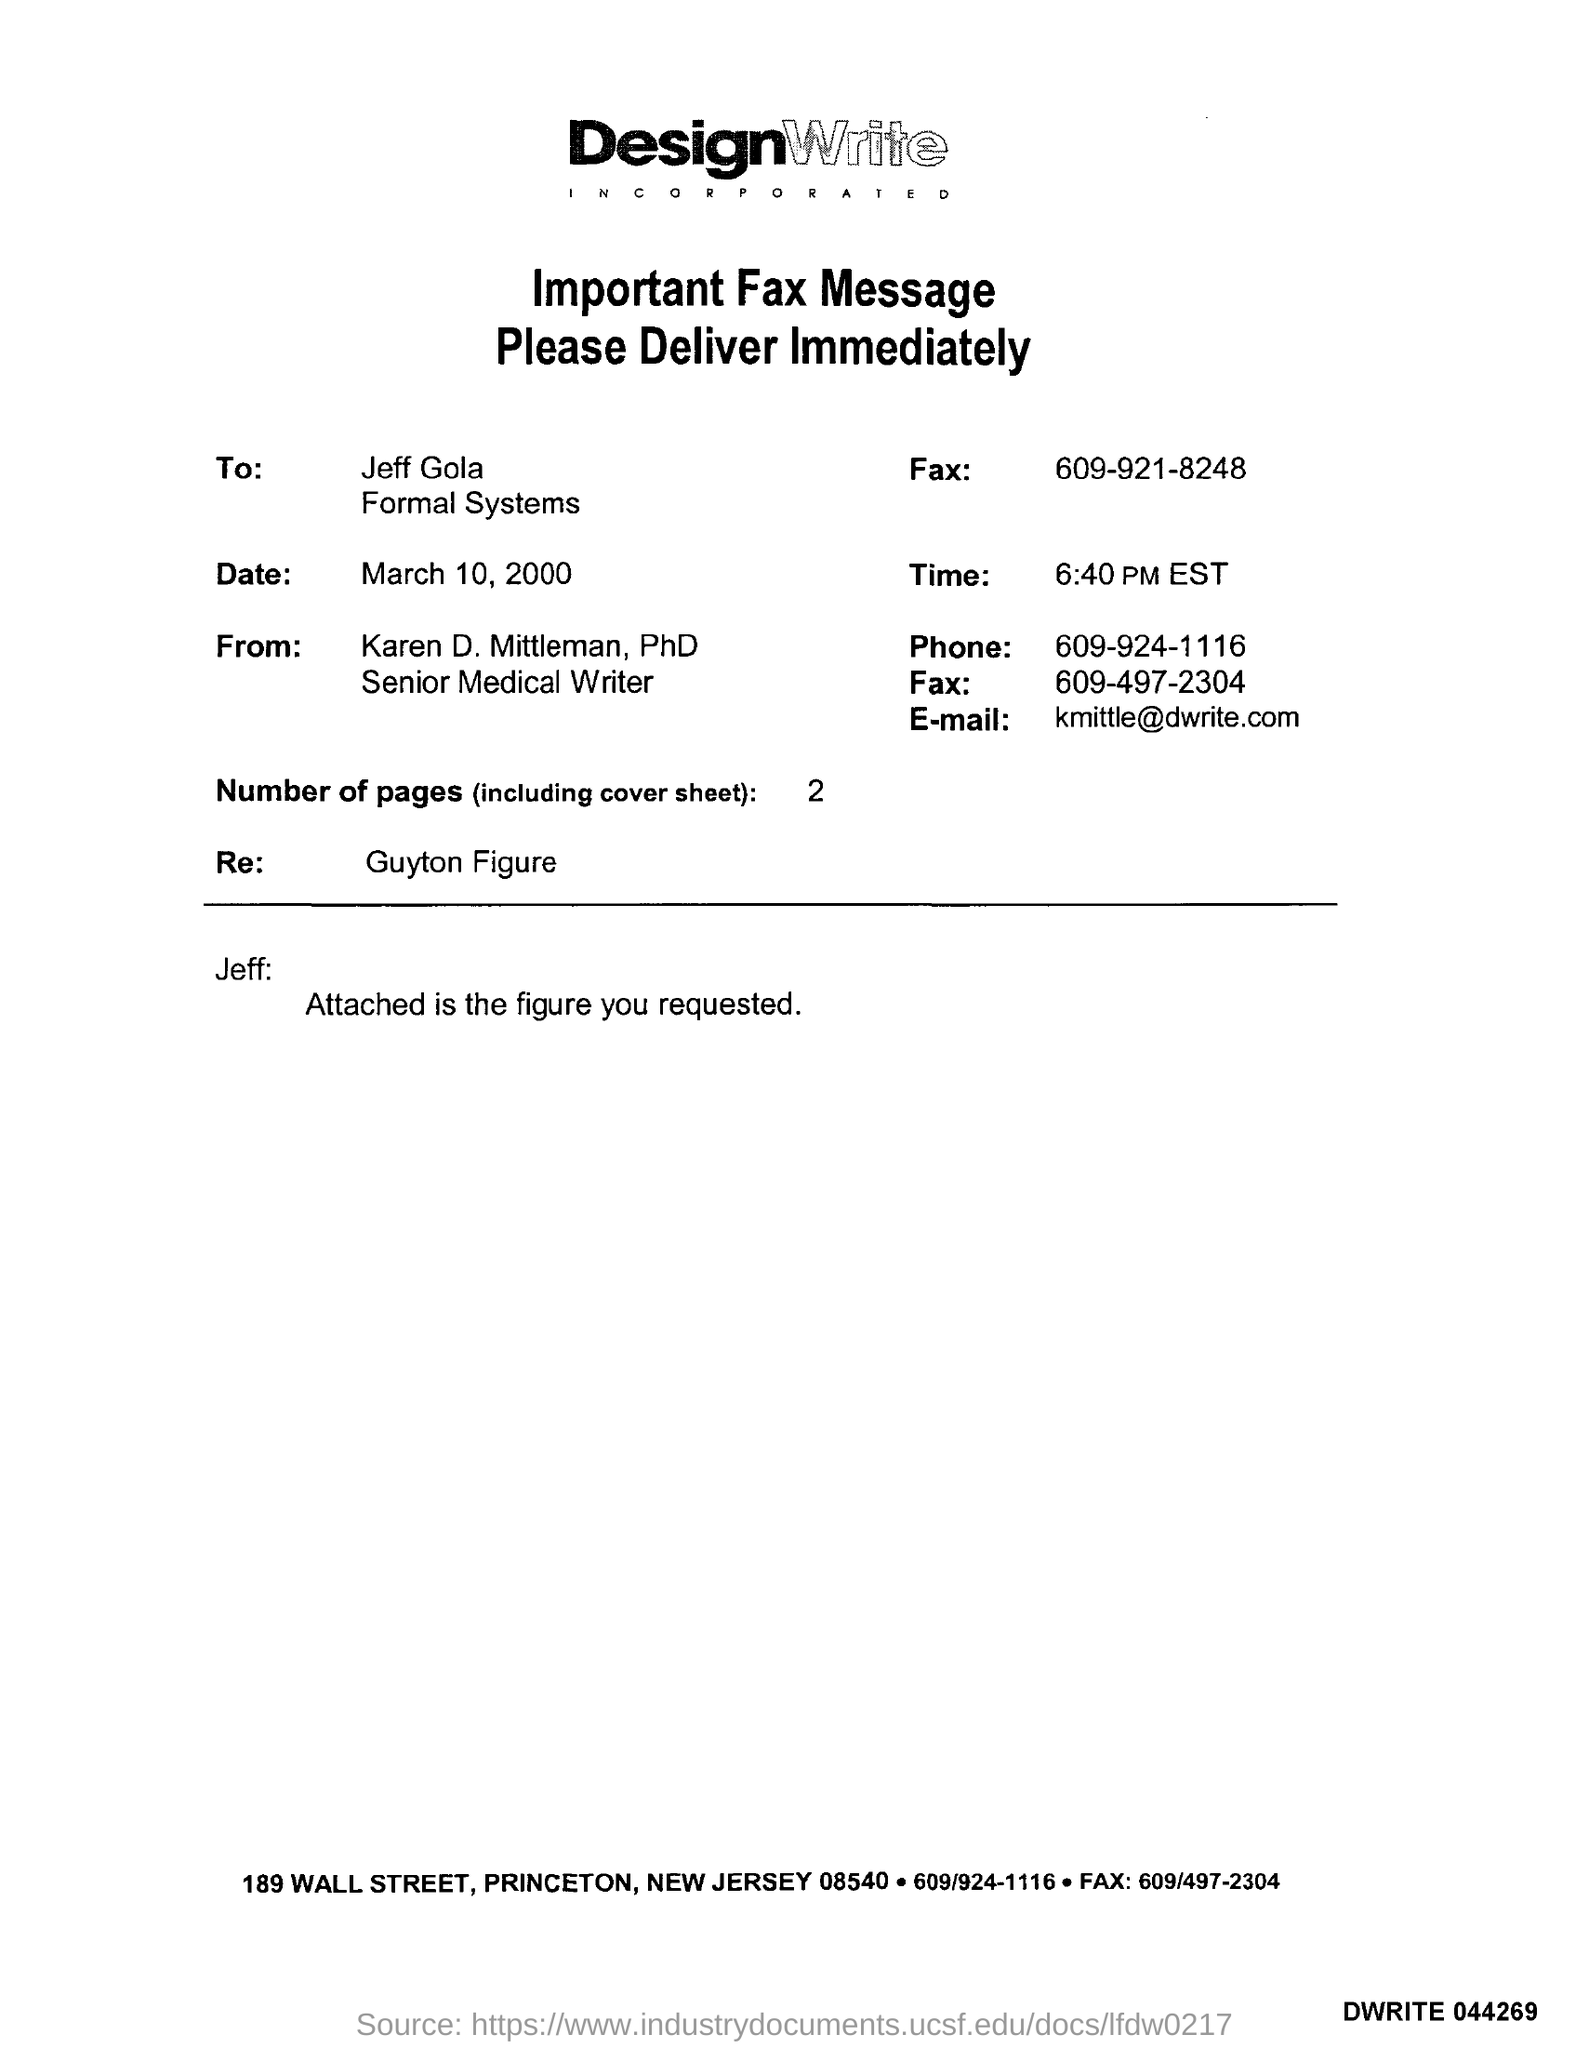Identify some key points in this picture. The Guyton figure mentioned in the fax message is a Re:. The time mentioned in the given fax message is 6:40 PM EST. The phone number mentioned in the fax is 609-924-1116. The date mentioned in the fax message is March 10, 2000. The person this fax was sent to is Jeff Gola. 